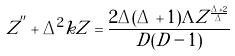<formula> <loc_0><loc_0><loc_500><loc_500>Z ^ { ^ { \prime \prime } } + \Delta ^ { 2 } k Z = \frac { 2 \Delta ( \Delta + 1 ) \Lambda Z ^ { \frac { \Delta + 2 } { \Delta } } } { D ( D - 1 ) }</formula> 